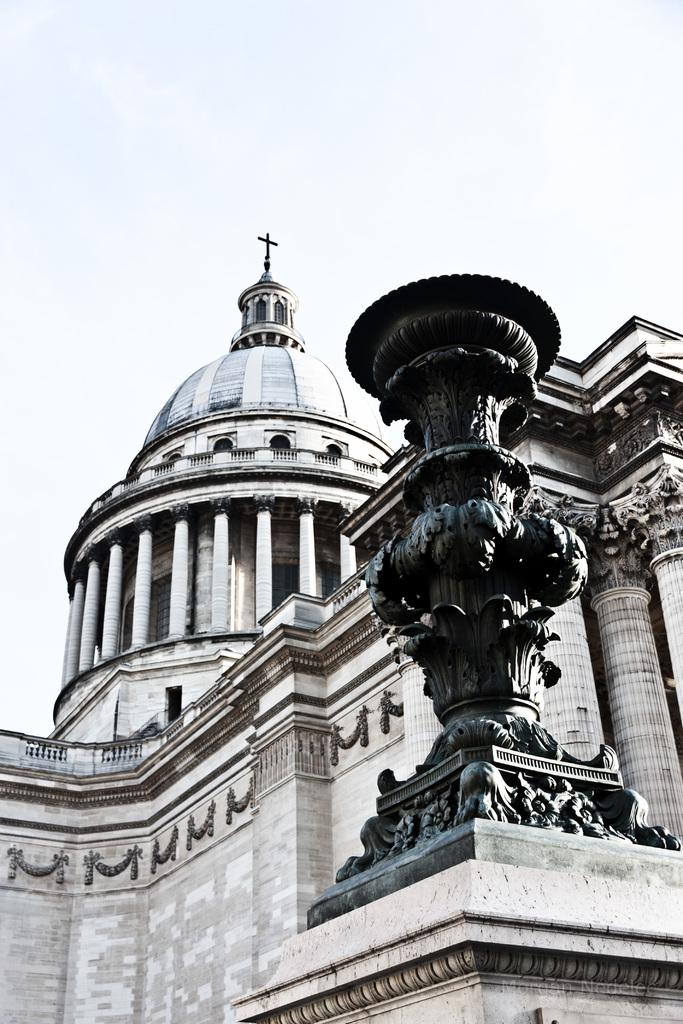What can be seen at the top of the image? The sky is visible towards the top of the image. What type of structure is present in the image? There is a building in the image. What artistic element can be found in the image? There is a sculpture in the image. Where is the pail located in the image? There is no pail present in the image. What type of garden can be seen in the image? There is no garden present in the image. 